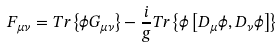Convert formula to latex. <formula><loc_0><loc_0><loc_500><loc_500>F _ { \mu \nu } = T r \left \{ \phi G _ { \mu \nu } \right \} - \frac { i } { g } T r \left \{ \phi \left [ D _ { \mu } \phi , D _ { \nu } \phi \right ] \right \}</formula> 